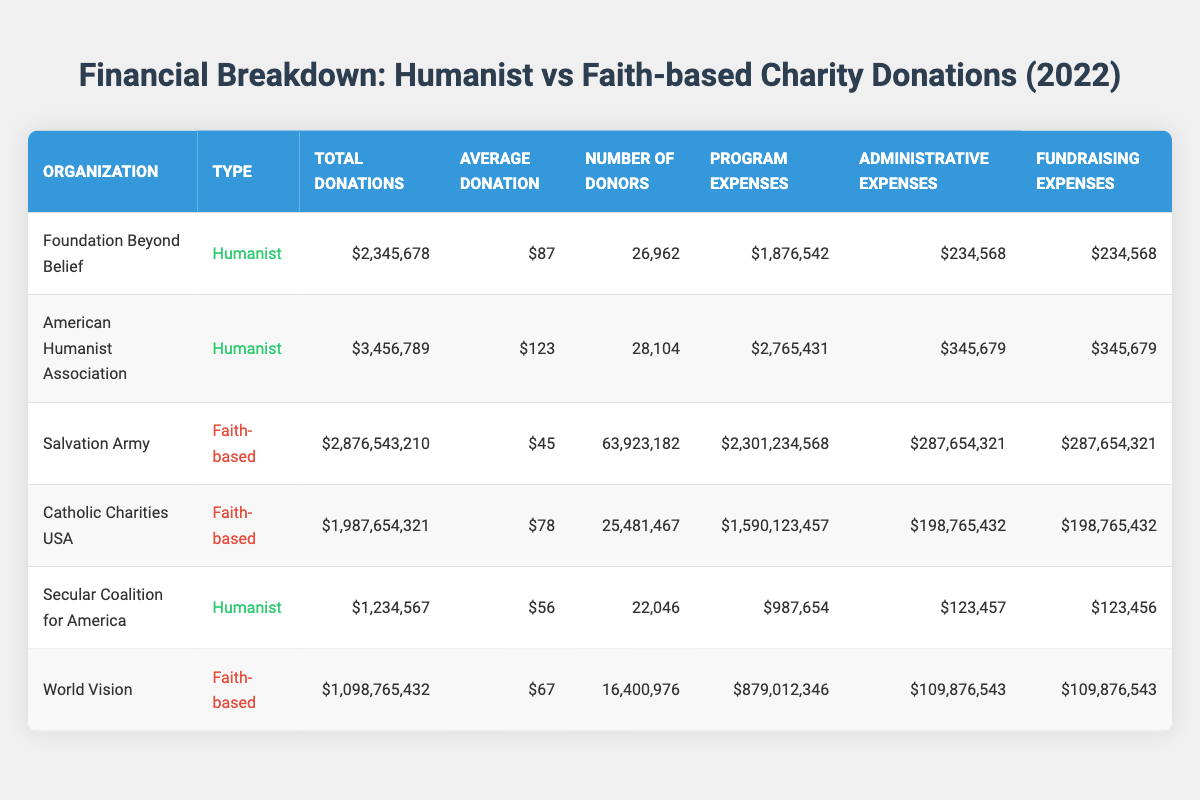What is the total donation amount for American Humanist Association? The table lists the total donations for each organization. For the American Humanist Association, the total donations amount is given as 3,456,789.
Answer: 3,456,789 Which faith-based organization has the highest number of donors? The Salvation Army has the highest number of donors at 63,923,182, which is shown in the number of donors column. The other faith-based organizations have fewer donors.
Answer: Salvation Army What is the average donation amount for all humanist organizations combined? First, sum the average donations for the humanist organizations: (87 + 123 + 56) = 266. There are 3 humanist organizations, so the average is 266 / 3 = 88.67.
Answer: 88.67 Is the program expense for the Catholic Charities USA higher than the total donations it received? The total donations for Catholic Charities USA are 1,987,654,321 and the program expenses are 1,590,123,457. Since 1,590,123,457 is less than 1,987,654,321, the answer is no.
Answer: No What is the total amount spent on fundraising expenses for faith-based organizations? The fundraising expenses for faith-based organizations are 287,654,321 (Salvation Army) + 198,765,432 (Catholic Charities USA) + 109,876,543 (World Vision) = 596,296,296.
Answer: 596,296,296 Which organization has the lowest total donations and what is that amount? Among the listed organizations, the Secular Coalition for America has the lowest total donations at 1,234,567, as shown in the total donations column.
Answer: 1,234,567 How much more does the Salvation Army spend on program expenses compared to the American Humanist Association? The Salvation Army spends 2,301,234,568 and American Humanist Association spends 2,765,431. The difference is 2,301,234,568 - 2,765,431 = 2,298,469,137.
Answer: 2,298,469,137 Is it true that every humanist organization has an average donation higher than the average donation of the faith-based organizations? The average donations for humanist organizations are 87, 123, and 56, giving a mean of 88.67. For faith-based organizations, the average donations are 45, 78, and 67, giving a mean of 63.33. Since 88.67 is higher than 63.33, the answer is yes.
Answer: Yes What percentage of total donations received by the Foundation Beyond Belief was spent on administrative expenses? Foundation Beyond Belief received 2,345,678 total donations and spent 234,568 on administrative expenses. The percentage is (234,568 / 2,345,678) * 100 = 10%.
Answer: 10% 